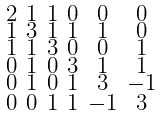<formula> <loc_0><loc_0><loc_500><loc_500>\begin{smallmatrix} 2 & 1 & 1 & 0 & 0 & 0 \\ 1 & 3 & 1 & 1 & 1 & 0 \\ 1 & 1 & 3 & 0 & 0 & 1 \\ 0 & 1 & 0 & 3 & 1 & 1 \\ 0 & 1 & 0 & 1 & 3 & - 1 \\ 0 & 0 & 1 & 1 & - 1 & 3 \end{smallmatrix}</formula> 